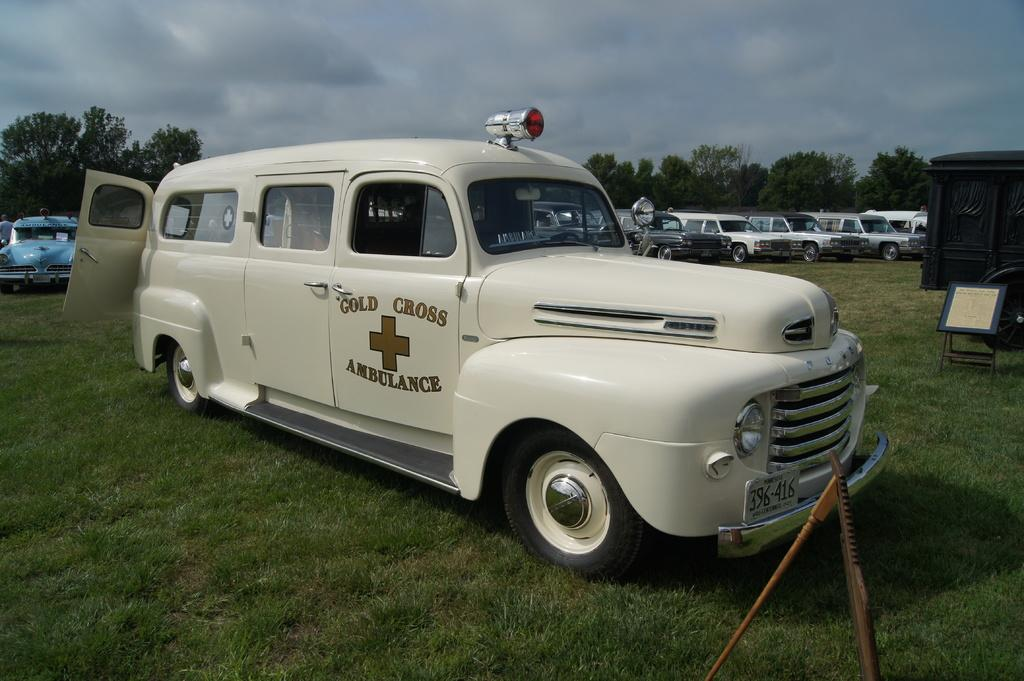<image>
Relay a brief, clear account of the picture shown. The white door on the truck reads gold cross ambulance 